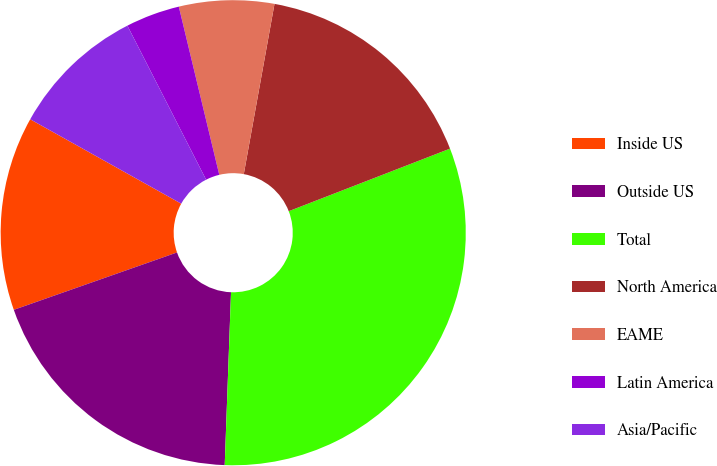Convert chart to OTSL. <chart><loc_0><loc_0><loc_500><loc_500><pie_chart><fcel>Inside US<fcel>Outside US<fcel>Total<fcel>North America<fcel>EAME<fcel>Latin America<fcel>Asia/Pacific<nl><fcel>13.49%<fcel>19.04%<fcel>31.47%<fcel>16.27%<fcel>6.6%<fcel>3.76%<fcel>9.37%<nl></chart> 